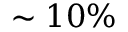Convert formula to latex. <formula><loc_0><loc_0><loc_500><loc_500>\sim 1 0 \%</formula> 